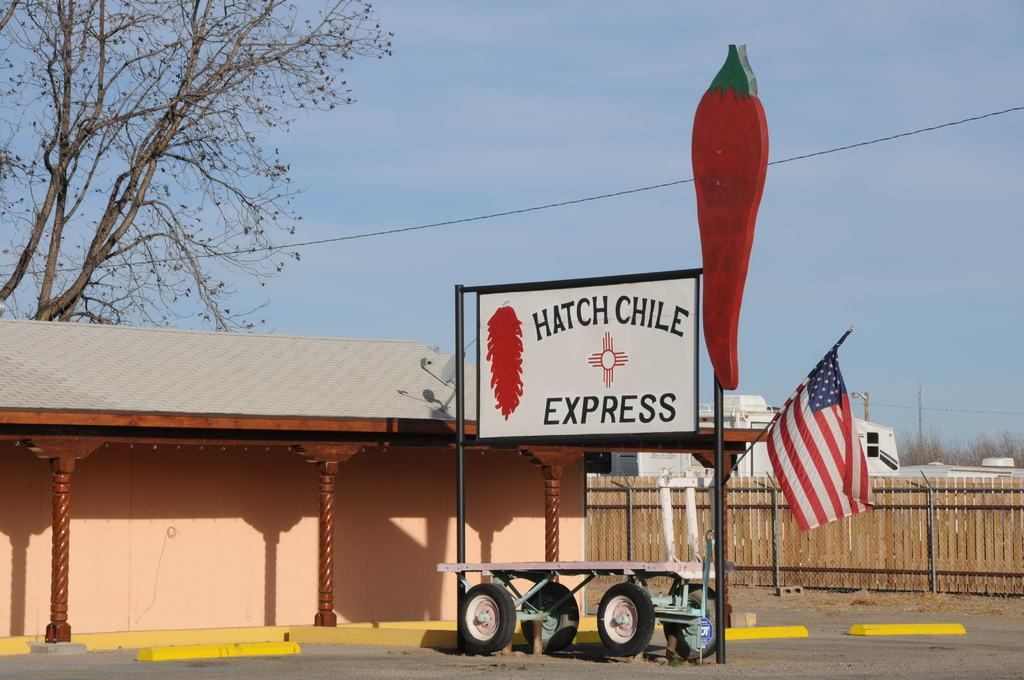What type of surface can be seen in the image? There is ground visible in the image. What color are the poles in the image? The poles in the image are black. What objects have wheels in the image? There are wheels in the image, but the specific objects with wheels are not mentioned. What type of vehicle is present in the image? There is an aboard in the image. What is attached to a pole in the image? There is a flag in the image, attached to a pole. What safety feature is present in the image? There is railing in the image. What type of structures can be seen in the image? There are buildings in the image. What type of vegetation can be seen in the image? There are trees in the image. What is visible in the background of the image? The sky is visible in the background of the image. Can you tell me how many donkeys are pulling the carriage in the image? There is no carriage or donkey present in the image. What type of can is visible in the image? There is no can present in the image. 